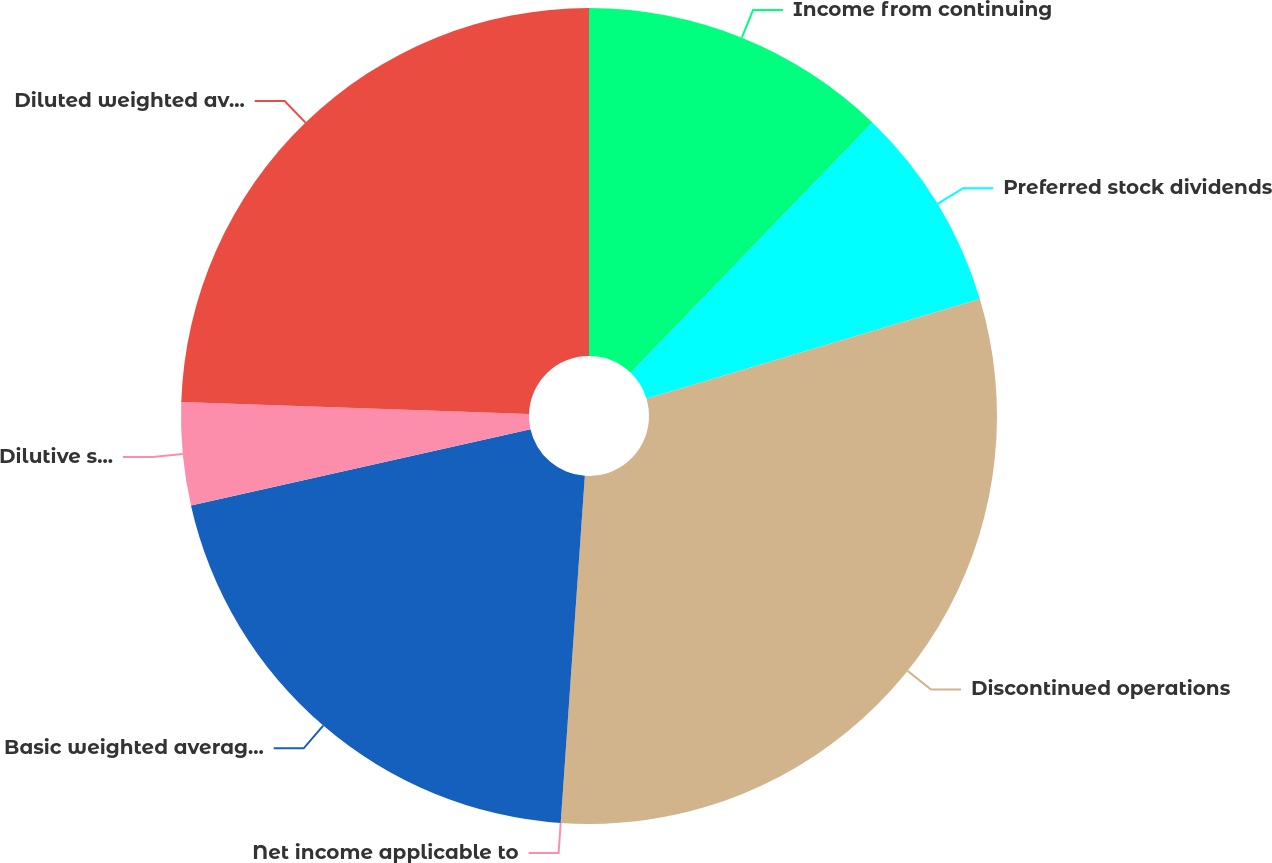Convert chart to OTSL. <chart><loc_0><loc_0><loc_500><loc_500><pie_chart><fcel>Income from continuing<fcel>Preferred stock dividends<fcel>Discontinued operations<fcel>Net income applicable to<fcel>Basic weighted average common<fcel>Dilutive stock options and<fcel>Diluted weighted average<nl><fcel>12.22%<fcel>8.15%<fcel>30.73%<fcel>0.0%<fcel>20.37%<fcel>4.07%<fcel>24.45%<nl></chart> 